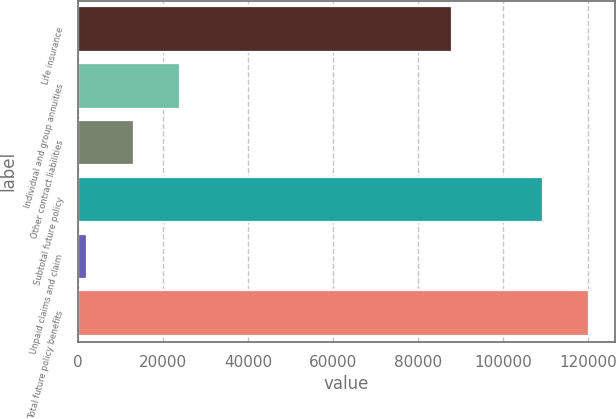Convert chart. <chart><loc_0><loc_0><loc_500><loc_500><bar_chart><fcel>Life insurance<fcel>Individual and group annuities<fcel>Other contract liabilities<fcel>Subtotal future policy<fcel>Unpaid claims and claim<fcel>Total future policy benefits<nl><fcel>88017<fcel>23976<fcel>13039.5<fcel>109365<fcel>2103<fcel>120302<nl></chart> 